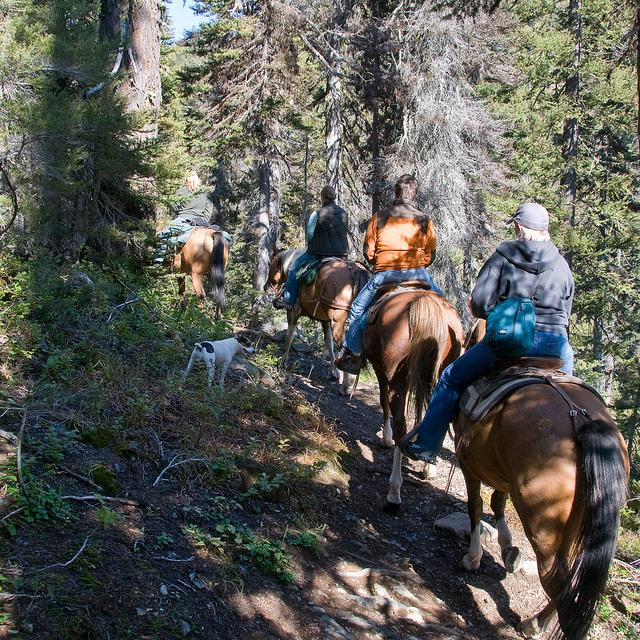Why are some trees here leafless? they're dead 